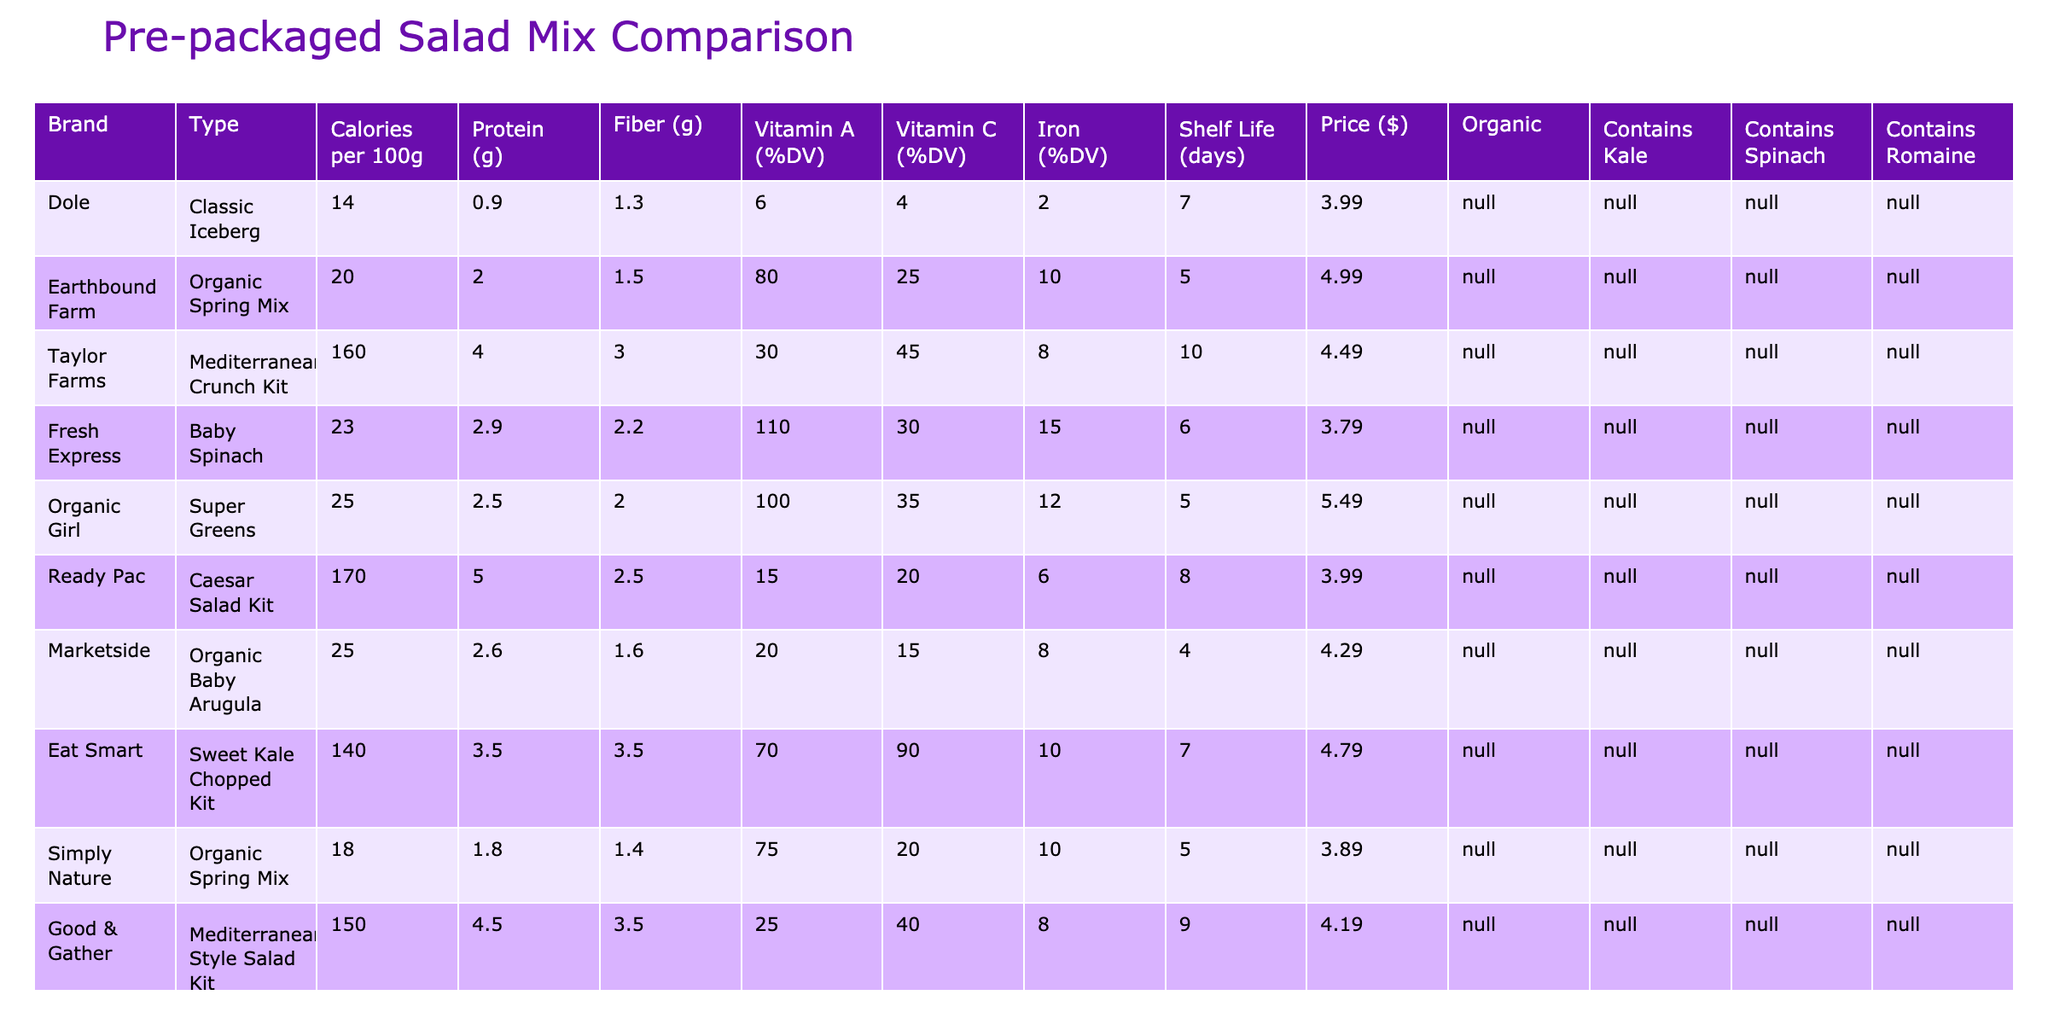What is the highest percentage of Vitamin C (%DV) in any of the salad mixes? The table shows the Vitamin C (%DV) for each salad mix. Scanning the values, the highest vitamin C content is 90% found in the Eat Smart Sweet Kale Chopped Kit.
Answer: 90% Which salad mix has the lowest calories per 100g? Looking at the Calories per 100g column, the Dole Classic Iceberg has the lowest value of 14 calories.
Answer: 14 Is the Organic Girl Super Greens organic? The table indicates the Organic column for Organic Girl is marked with '✓', confirming that it is organic.
Answer: Yes What is the price difference between the Dole Classic Iceberg and the Earthbound Farm Organic Spring Mix? Dole Classic Iceberg is priced at $3.99, while Earthbound Farm Organic Spring Mix is $4.99. Calculating the difference: $4.99 - $3.99 = $1.00.
Answer: $1.00 Which salad mix contains both Kale and Spinach? The table includes a column for Contains Kale and another for Contains Spinach. Only the Organic Girl Super Greens and the Good & Gather Mediterranean Style Salad Kit contain both, as indicated with '✓' in respective columns.
Answer: Organic Girl Super Greens, Good & Gather Mediterranean Style Salad Kit How many salad mixes have a shelf life of more than 7 days? Reviewing the Shelf Life (days) column, we count the entries greater than 7 days. They are: Taylor Farms Mediterranean Crunch Kit (10 days), Good & Gather Mediterranean Style Salad Kit (9 days), and Ready Pac Caesar Salad Kit (8 days). Thus, there are three salad mixes.
Answer: 3 Which salad mix has the highest protein content? The Protein (g) column shows each salad's protein content. The Taylor Farms Mediterranean Crunch Kit has the highest protein content at 5.0g.
Answer: 5.0g Are there any salad mixes that contain Romaine and are also organic? Checking the Contains Romaine and Organic columns, only the Good & Gather Mediterranean Style Salad Kit meets both criteria, marked as '✓' for both.
Answer: Yes What is the average number of days of shelf life across all salad mixes listed? To compute the average shelf life, sum all the days (7 + 5 + 10 + 6 + 5 + 8 + 4 + 7 + 5 + 9 = 66) and divide by 10, giving an average of 6.6 days.
Answer: 6.6 days Which salad mix contains no protein? Searching the Protein (g) column, the Dole Classic Iceberg has the lowest protein content at 0.9g; however, there are no salad mixes with 0g of protein, but this is the lowest.
Answer: None Which salad mix offers the best combination of low calories and high Vitamin A (%DV)? Evaluating the table, the Earthbound Farm Organic Spring Mix has the lowest calories (20) and a high Vitamin A content (80% DV), making it a good option for low calories and high vitamin A.
Answer: Earthbound Farm Organic Spring Mix 